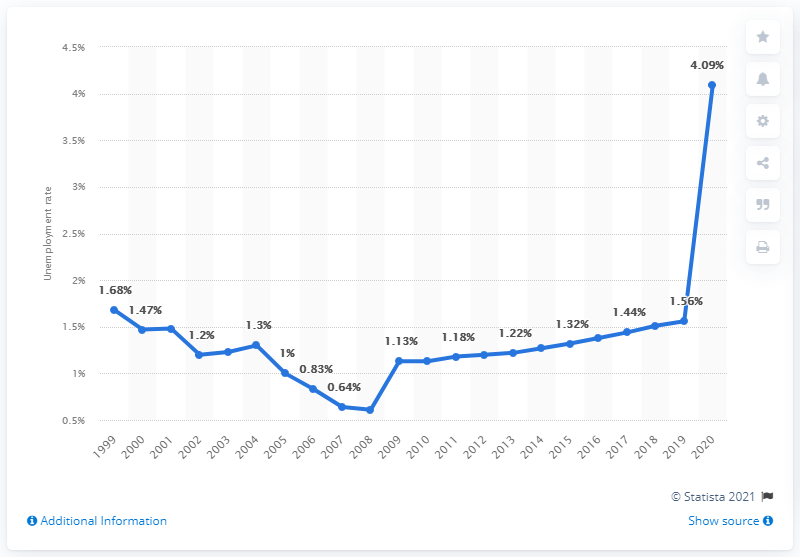Give some essential details in this illustration. In 2020, the unemployment rate in Bahrain was 4.09%. 